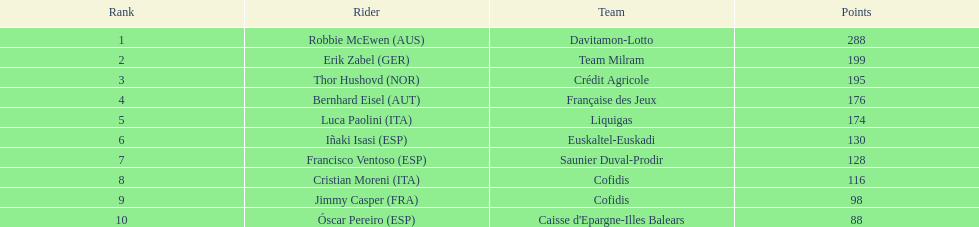How many points did robbie mcewen and cristian moreni score together? 404. Could you help me parse every detail presented in this table? {'header': ['Rank', 'Rider', 'Team', 'Points'], 'rows': [['1', 'Robbie McEwen\xa0(AUS)', 'Davitamon-Lotto', '288'], ['2', 'Erik Zabel\xa0(GER)', 'Team Milram', '199'], ['3', 'Thor Hushovd\xa0(NOR)', 'Crédit Agricole', '195'], ['4', 'Bernhard Eisel\xa0(AUT)', 'Française des Jeux', '176'], ['5', 'Luca Paolini\xa0(ITA)', 'Liquigas', '174'], ['6', 'Iñaki Isasi\xa0(ESP)', 'Euskaltel-Euskadi', '130'], ['7', 'Francisco Ventoso\xa0(ESP)', 'Saunier Duval-Prodir', '128'], ['8', 'Cristian Moreni\xa0(ITA)', 'Cofidis', '116'], ['9', 'Jimmy Casper\xa0(FRA)', 'Cofidis', '98'], ['10', 'Óscar Pereiro\xa0(ESP)', "Caisse d'Epargne-Illes Balears", '88']]} 